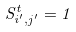Convert formula to latex. <formula><loc_0><loc_0><loc_500><loc_500>S _ { i ^ { \prime } , j ^ { \prime } } ^ { t } = 1</formula> 